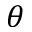Convert formula to latex. <formula><loc_0><loc_0><loc_500><loc_500>\theta</formula> 